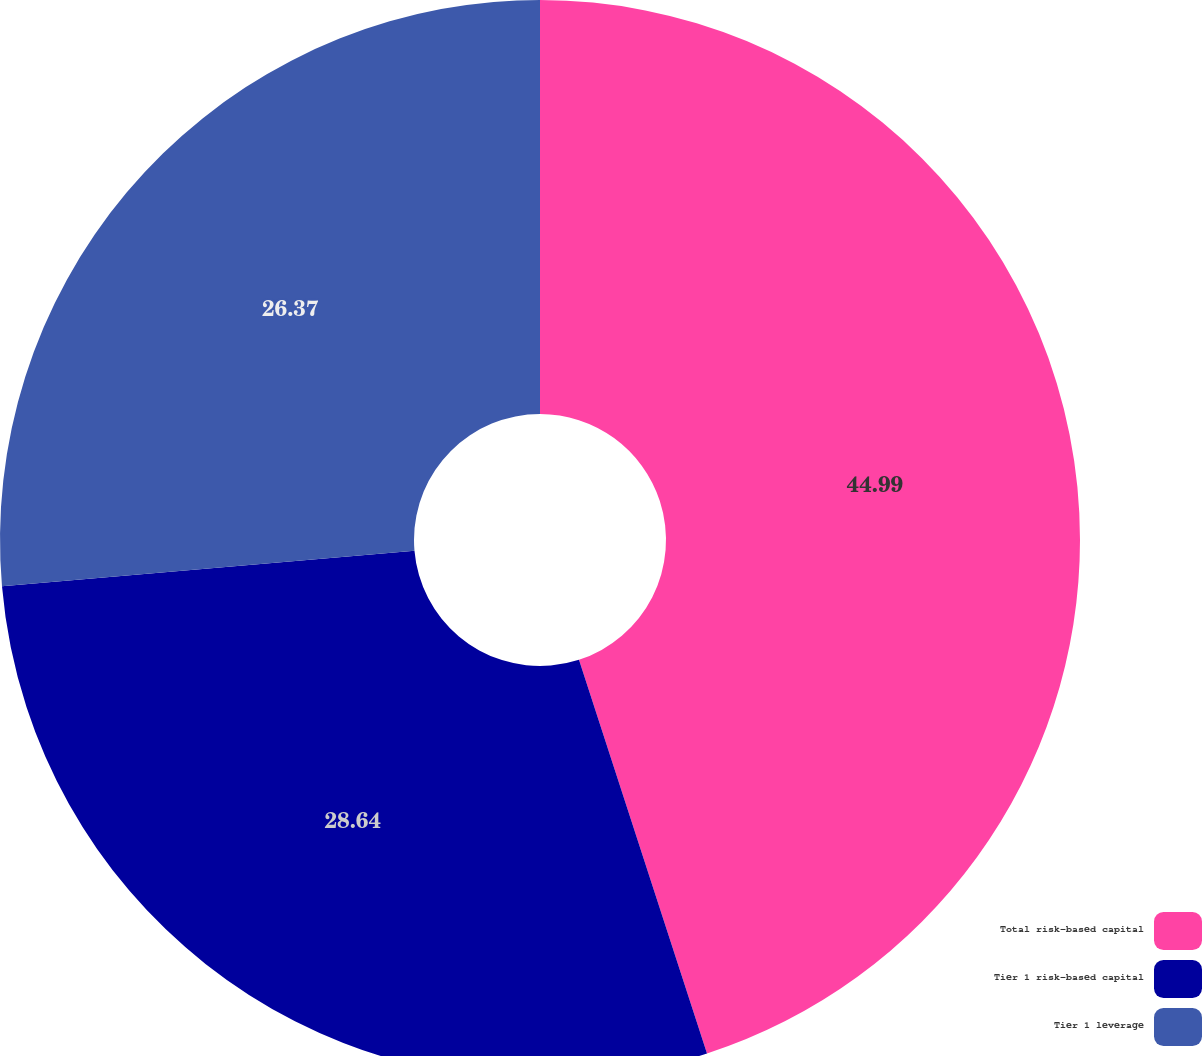<chart> <loc_0><loc_0><loc_500><loc_500><pie_chart><fcel>Total risk-based capital<fcel>Tier 1 risk-based capital<fcel>Tier 1 leverage<nl><fcel>45.0%<fcel>28.64%<fcel>26.37%<nl></chart> 